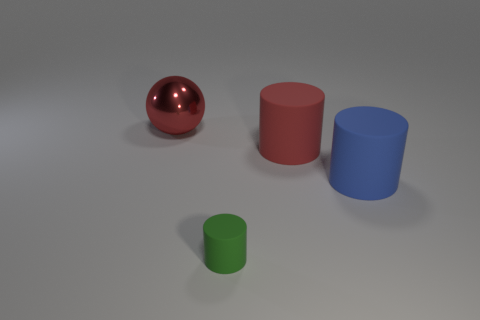Subtract all big cylinders. How many cylinders are left? 1 Add 4 big purple metallic cylinders. How many objects exist? 8 Subtract 2 cylinders. How many cylinders are left? 1 Subtract all cylinders. How many objects are left? 1 Subtract all yellow spheres. Subtract all cyan cubes. How many spheres are left? 1 Subtract all cyan spheres. How many blue cylinders are left? 1 Subtract all blue matte cylinders. Subtract all tiny purple cubes. How many objects are left? 3 Add 1 big metallic objects. How many big metallic objects are left? 2 Add 3 large rubber things. How many large rubber things exist? 5 Subtract all blue cylinders. How many cylinders are left? 2 